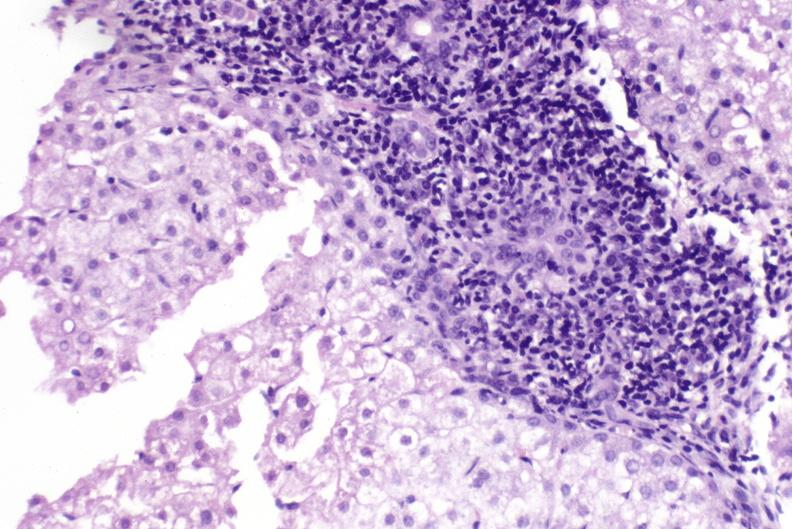what does this image show?
Answer the question using a single word or phrase. Primary biliary cirrhosis 